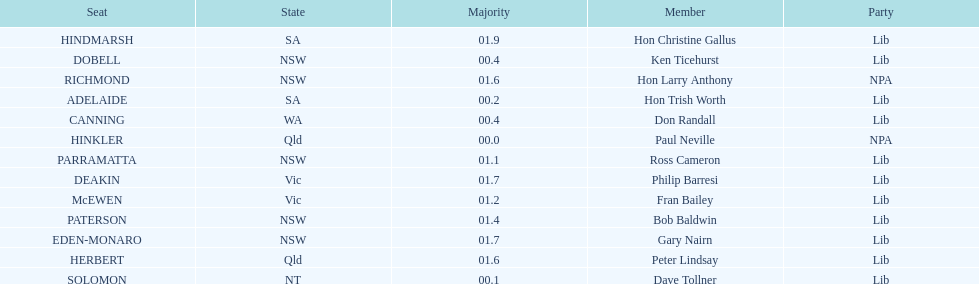What is the difference in majority between hindmarsh and hinkler? 01.9. 